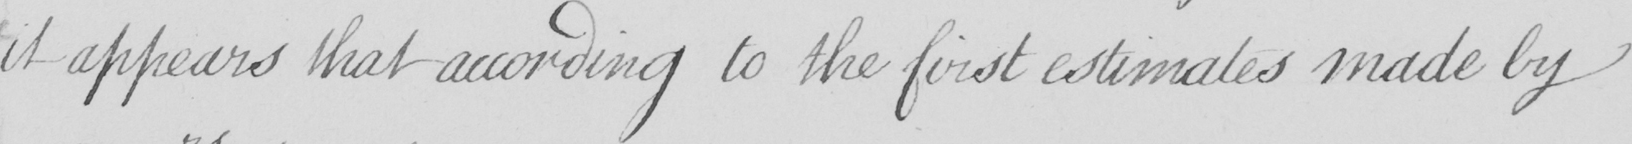Please transcribe the handwritten text in this image. it appears that according to the first estimates made by 